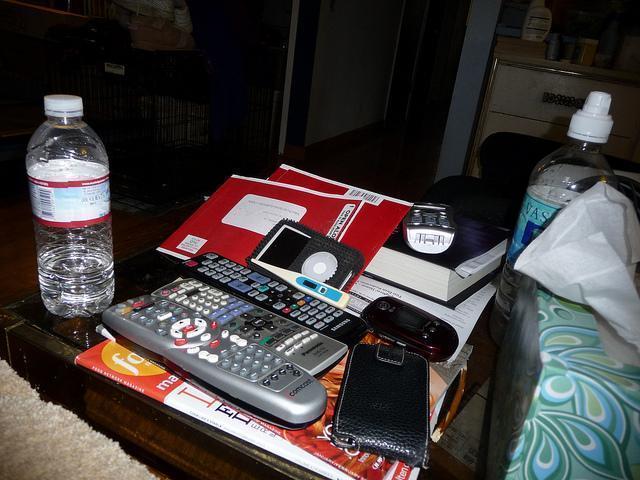The red envelopes on the table indicate that there is what electronic device in the room?
Indicate the correct response and explain using: 'Answer: answer
Rationale: rationale.'
Options: Dvd player, vhs player, cd player, cable box. Answer: dvd player.
Rationale: These types of envelopes were commonly used with movie discs at one point. 